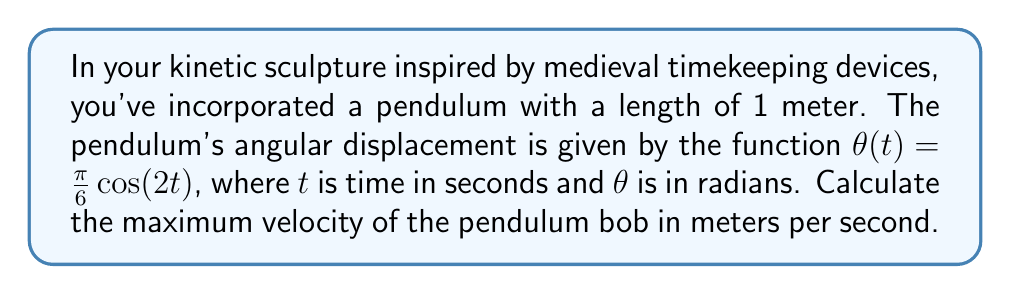Teach me how to tackle this problem. To solve this problem, we'll follow these steps:

1) The velocity of a pendulum bob is given by $v = l\frac{d\theta}{dt}$, where $l$ is the length of the pendulum.

2) We need to find $\frac{d\theta}{dt}$:
   $$\frac{d\theta}{dt} = \frac{d}{dt}[\frac{\pi}{6} \cos(2t)] = -\frac{\pi}{3}\sin(2t)$$

3) Now, the velocity function is:
   $$v(t) = l\frac{d\theta}{dt} = -\frac{\pi}{3}\sin(2t)$$

4) To find the maximum velocity, we need the maximum absolute value of this function. The maximum value of $\sin(2t)$ is 1, so:

   $$|v_{max}| = l \cdot \frac{\pi}{3} = 1 \cdot \frac{\pi}{3} \approx 1.047$$

5) Therefore, the maximum velocity is approximately 1.047 m/s.
Answer: $\frac{\pi}{3}$ m/s 